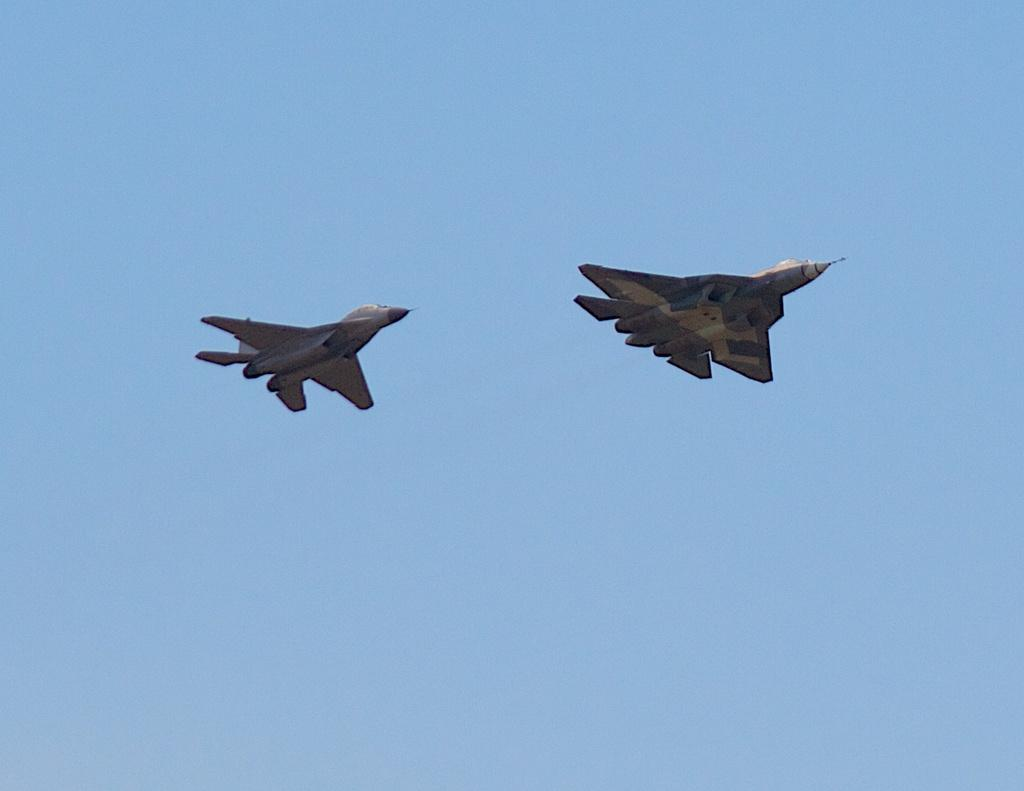What is the main subject of the image? The main subject of the image is jets. What can be seen in the background of the image? There is a sky visible in the background of the image. How many oranges are hanging from the kite in the image? There are no oranges or kites present in the image. Can you describe the sheep grazing in the foreground of the image? There are no sheep in the image; the main subject is jets. 